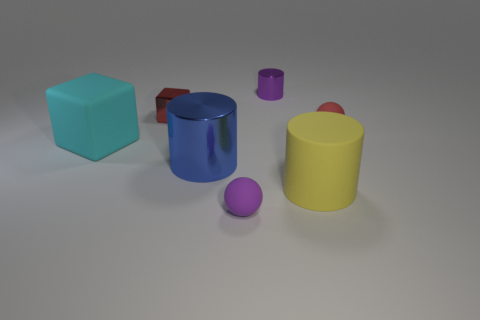The small object that is in front of the large rubber object that is on the left side of the ball that is in front of the red matte sphere is what shape?
Make the answer very short. Sphere. There is a metal cylinder that is on the left side of the small purple ball; is its color the same as the rubber ball that is in front of the cyan block?
Ensure brevity in your answer.  No. What number of cyan matte cylinders are there?
Keep it short and to the point. 0. Are there any small red blocks in front of the big cyan object?
Give a very brief answer. No. Is the material of the red thing to the left of the tiny purple rubber thing the same as the tiny purple object that is behind the purple matte ball?
Make the answer very short. Yes. Are there fewer tiny metallic cylinders that are in front of the red metal cube than rubber spheres?
Make the answer very short. Yes. What is the color of the big rubber thing that is on the right side of the blue metal cylinder?
Provide a short and direct response. Yellow. What material is the large yellow thing on the right side of the big cylinder left of the purple ball?
Your answer should be very brief. Rubber. Is there another object that has the same size as the red shiny thing?
Provide a short and direct response. Yes. How many things are matte things that are in front of the large cyan matte cube or small matte spheres in front of the rubber block?
Offer a very short reply. 2. 